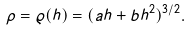Convert formula to latex. <formula><loc_0><loc_0><loc_500><loc_500>\rho = \varrho ( h ) = ( a h + b h ^ { 2 } ) ^ { 3 / 2 } .</formula> 